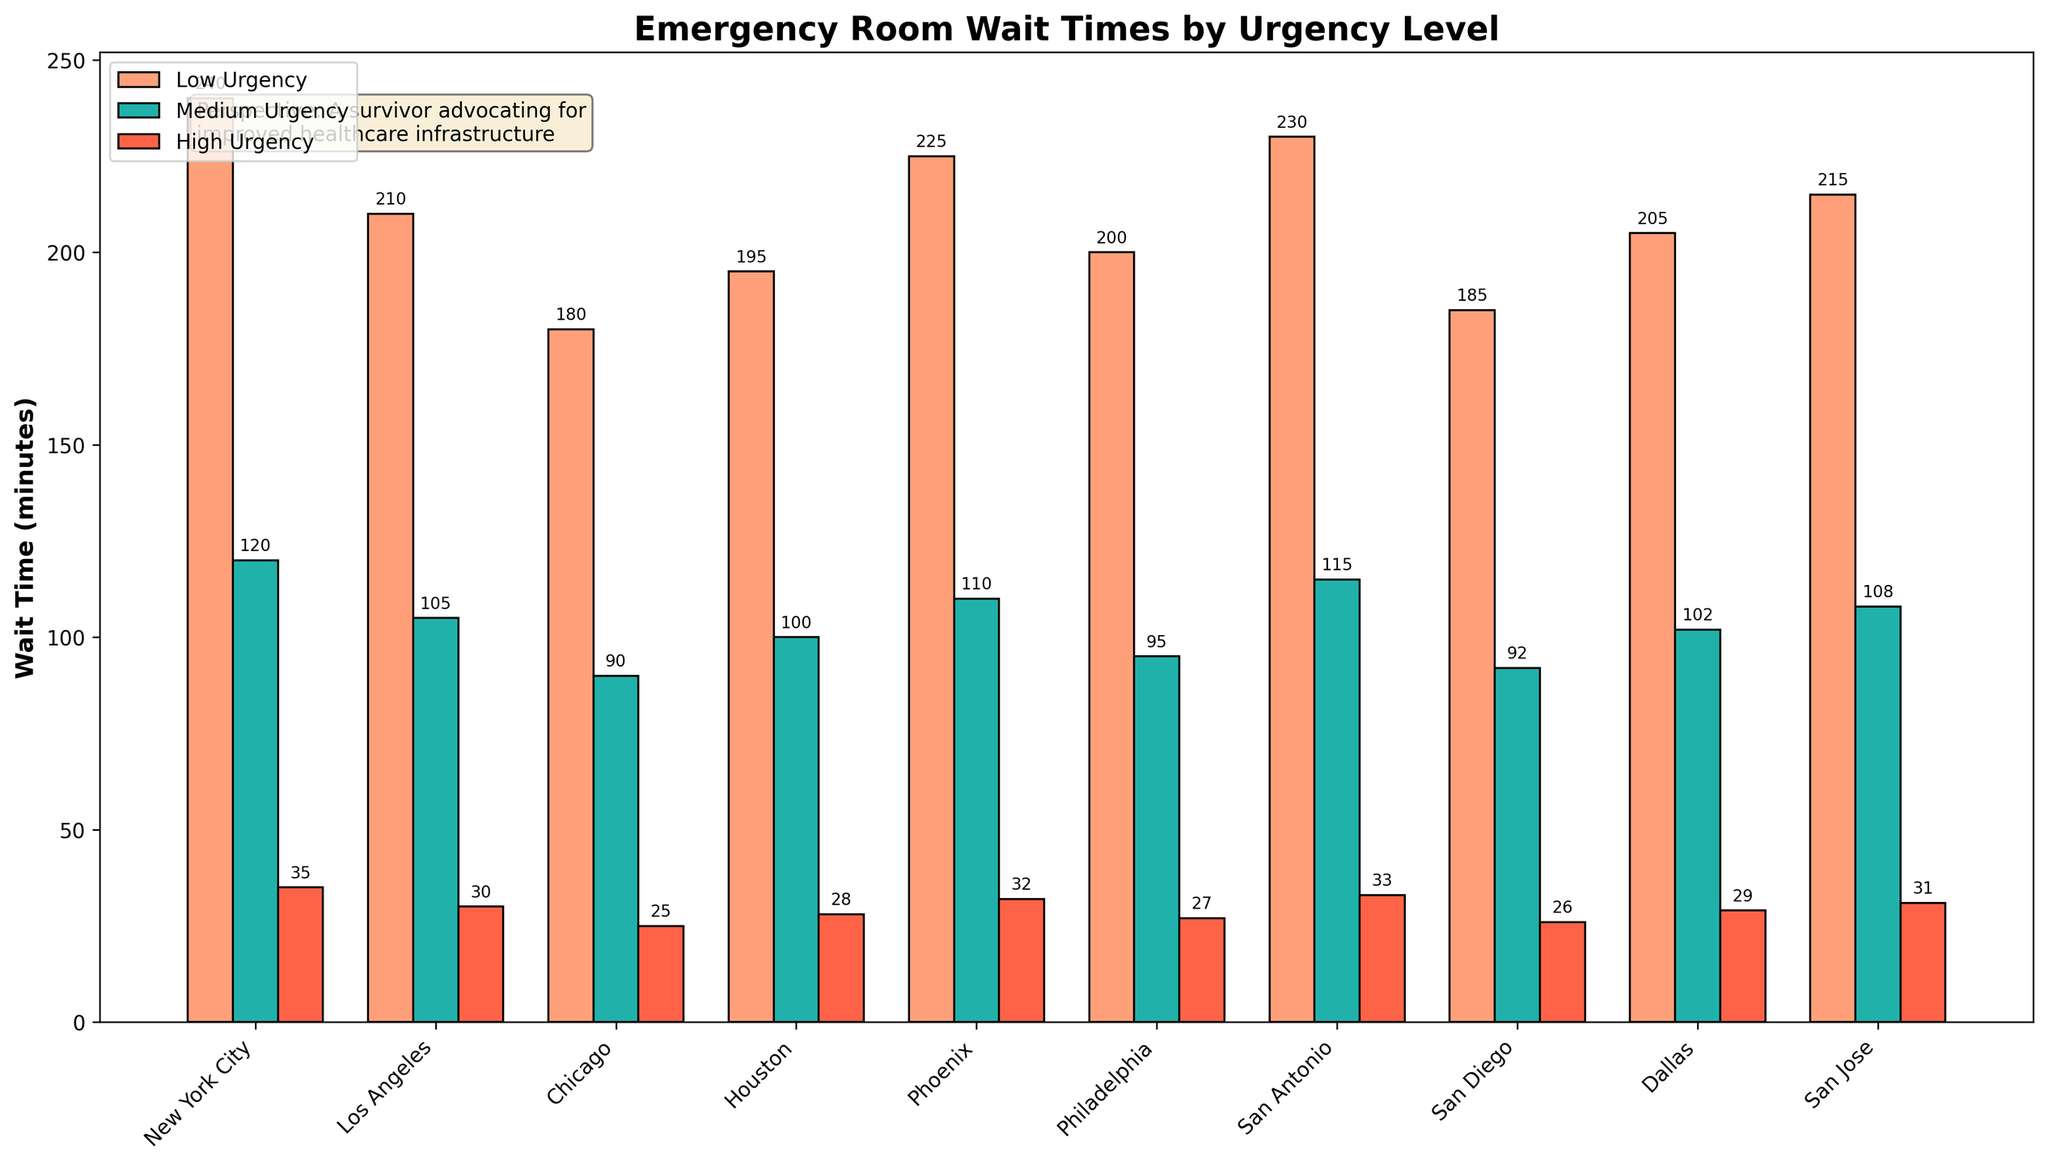what's the average wait time for medium urgency cases across all 10 cities? Sum the wait times for medium urgency cases in the top 10 cities: 120 + 105 + 90 + 100 + 110 + 95 + 115 + 92 + 102 + 108. Then, divide by the number of cities, which is 10. (120 + 105 + 90 + 100 + 110 + 95 + 115 + 92 + 102 + 108) / 10 = 1037 / 10 = 103.7
Answer: 103.7 Which city has the shortest wait time for high urgency cases? Check the heights of the red bars corresponding to high urgency cases for each city and identify the shortest one. New York City has the shortest wait time at 35 minutes.
Answer: New York City What is the difference between the highest and the lowest wait times for low urgency cases among the cities shown? Find the tallest and shortest orange bars corresponding to low urgency cases, which belong to New York City (240 minutes) and Columbus (175 minutes), respectively. The difference is 240 - 175 = 65.
Answer: 65 By how much does the medium urgency wait time in Phoenix exceed that in Chicago? Compare the heights of the green bars for Phoenix (110 minutes) and Chicago (90 minutes). The difference is 110 - 90 = 20.
Answer: 20 What is the total combined wait time for all urgency levels in Dallas? Add the wait times for low (205 minutes), medium (102 minutes), and high urgency (29 minutes) in Dallas. 205 + 102 + 29 = 336.
Answer: 336 How does the average wait time for high urgency cases compare to the average wait time for low urgency cases across the displayed cities? Calculate the average wait time for high urgency cases (sum of high urgency times divided by 10) and for low urgency cases (sum of low urgency times divided by 10). High urgency average: (35 + 30 + 25 + 28 + 32 + 27 + 33 + 26 + 29 + 31) / 10 = 296 / 10 = 29.6. Low urgency average: (240 + 210 + 180 + 195 + 225 + 200 + 230 + 185 + 205 + 215) / 10 = 2095 / 10 = 209.5. Compare the two averages: 209.5 vs. 29.6.
Answer: Low urgency: 209.5, High urgency: 29.6 Which has the longest wait time for medium urgency cases among the displayed cities, and how much longer is it compared to the shortest wait time? Identify the longest green bar (New York City at 120 minutes) and the shortest green bar (Chicago at 90 minutes). The difference is 120 - 90 = 30.
Answer: New York City, 30 In the city of Houston, is the medium urgency wait time greater than the wait time for low urgency? If not, by how much? Check the heights of the bars for medium urgency (100 minutes) and low urgency (195 minutes) in Houston. The medium urgency wait time is not greater. The difference is 195 - 100 = 95.
Answer: No, by 95 Which two cities have the same wait times for medium urgency cases and what is that wait time? Look for cities with green bars of the same height for medium urgency cases. Phoenix and Jacksonville both have a wait time of 110 minutes for medium urgency cases.
Answer: Phoenix and Jacksonville, 110 How much longer are the wait times for low urgency compared to high urgency cases on average across the ten cities? Calculate the average wait times: Low urgency average = (240 + 210 + 180 + 195 + 225 + 200 + 230 + 185 + 205 + 215) / 10 = 209.5. High urgency average = (35 + 30 + 25 + 28 + 32 + 27 + 33 + 26 + 29 + 31) / 10 = 29.6. The difference is 209.5 - 29.6 = 179.9.
Answer: 179.9 